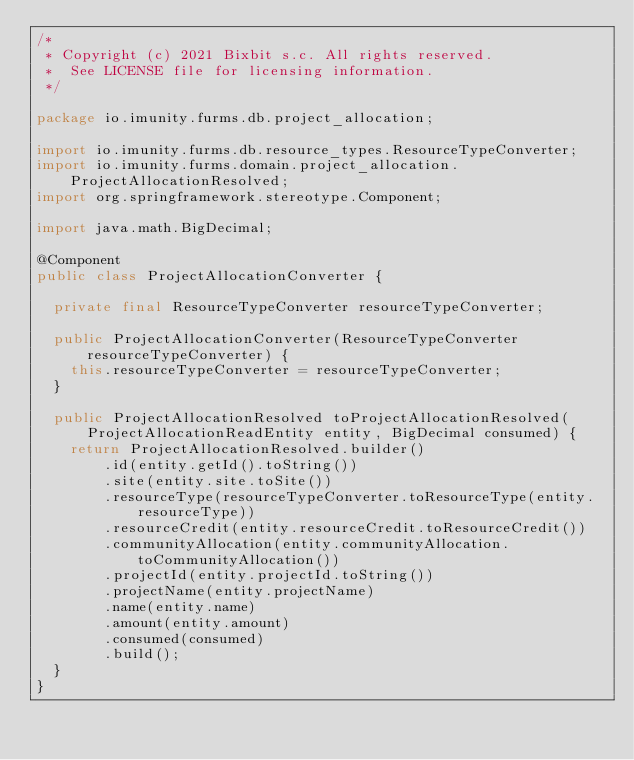Convert code to text. <code><loc_0><loc_0><loc_500><loc_500><_Java_>/*
 * Copyright (c) 2021 Bixbit s.c. All rights reserved.
 *  See LICENSE file for licensing information.
 */

package io.imunity.furms.db.project_allocation;

import io.imunity.furms.db.resource_types.ResourceTypeConverter;
import io.imunity.furms.domain.project_allocation.ProjectAllocationResolved;
import org.springframework.stereotype.Component;

import java.math.BigDecimal;

@Component
public class ProjectAllocationConverter {

	private final ResourceTypeConverter resourceTypeConverter;

	public ProjectAllocationConverter(ResourceTypeConverter resourceTypeConverter) {
		this.resourceTypeConverter = resourceTypeConverter;
	}

	public ProjectAllocationResolved toProjectAllocationResolved(ProjectAllocationReadEntity entity, BigDecimal consumed) {
		return ProjectAllocationResolved.builder()
				.id(entity.getId().toString())
				.site(entity.site.toSite())
				.resourceType(resourceTypeConverter.toResourceType(entity.resourceType))
				.resourceCredit(entity.resourceCredit.toResourceCredit())
				.communityAllocation(entity.communityAllocation.toCommunityAllocation())
				.projectId(entity.projectId.toString())
				.projectName(entity.projectName)
				.name(entity.name)
				.amount(entity.amount)
				.consumed(consumed)
				.build();
	}
}
</code> 